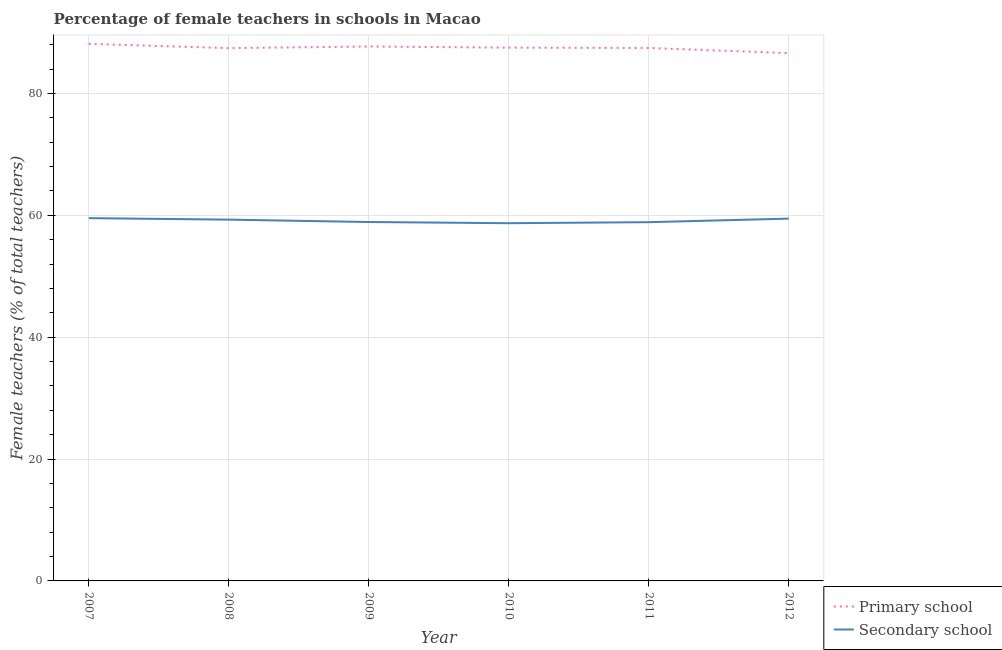How many different coloured lines are there?
Offer a terse response. 2. What is the percentage of female teachers in secondary schools in 2009?
Provide a short and direct response. 58.9. Across all years, what is the maximum percentage of female teachers in secondary schools?
Give a very brief answer. 59.53. Across all years, what is the minimum percentage of female teachers in primary schools?
Keep it short and to the point. 86.61. In which year was the percentage of female teachers in secondary schools maximum?
Give a very brief answer. 2007. In which year was the percentage of female teachers in secondary schools minimum?
Your response must be concise. 2010. What is the total percentage of female teachers in secondary schools in the graph?
Keep it short and to the point. 354.73. What is the difference between the percentage of female teachers in secondary schools in 2008 and that in 2009?
Your answer should be very brief. 0.39. What is the difference between the percentage of female teachers in primary schools in 2007 and the percentage of female teachers in secondary schools in 2012?
Your answer should be very brief. 28.68. What is the average percentage of female teachers in primary schools per year?
Keep it short and to the point. 87.47. In the year 2007, what is the difference between the percentage of female teachers in secondary schools and percentage of female teachers in primary schools?
Ensure brevity in your answer.  -28.6. In how many years, is the percentage of female teachers in secondary schools greater than 72 %?
Your answer should be compact. 0. What is the ratio of the percentage of female teachers in primary schools in 2008 to that in 2011?
Your answer should be very brief. 1. What is the difference between the highest and the second highest percentage of female teachers in primary schools?
Give a very brief answer. 0.44. What is the difference between the highest and the lowest percentage of female teachers in secondary schools?
Give a very brief answer. 0.83. How many lines are there?
Keep it short and to the point. 2. How many years are there in the graph?
Provide a succinct answer. 6. Does the graph contain grids?
Keep it short and to the point. Yes. How are the legend labels stacked?
Your answer should be compact. Vertical. What is the title of the graph?
Give a very brief answer. Percentage of female teachers in schools in Macao. What is the label or title of the X-axis?
Your answer should be very brief. Year. What is the label or title of the Y-axis?
Keep it short and to the point. Female teachers (% of total teachers). What is the Female teachers (% of total teachers) of Primary school in 2007?
Your response must be concise. 88.13. What is the Female teachers (% of total teachers) in Secondary school in 2007?
Make the answer very short. 59.53. What is the Female teachers (% of total teachers) in Primary school in 2008?
Keep it short and to the point. 87.43. What is the Female teachers (% of total teachers) of Secondary school in 2008?
Your response must be concise. 59.29. What is the Female teachers (% of total teachers) of Primary school in 2009?
Ensure brevity in your answer.  87.7. What is the Female teachers (% of total teachers) in Secondary school in 2009?
Offer a terse response. 58.9. What is the Female teachers (% of total teachers) of Primary school in 2010?
Offer a very short reply. 87.51. What is the Female teachers (% of total teachers) of Secondary school in 2010?
Offer a very short reply. 58.7. What is the Female teachers (% of total teachers) of Primary school in 2011?
Offer a very short reply. 87.45. What is the Female teachers (% of total teachers) in Secondary school in 2011?
Give a very brief answer. 58.87. What is the Female teachers (% of total teachers) of Primary school in 2012?
Make the answer very short. 86.61. What is the Female teachers (% of total teachers) in Secondary school in 2012?
Give a very brief answer. 59.45. Across all years, what is the maximum Female teachers (% of total teachers) of Primary school?
Make the answer very short. 88.13. Across all years, what is the maximum Female teachers (% of total teachers) in Secondary school?
Make the answer very short. 59.53. Across all years, what is the minimum Female teachers (% of total teachers) in Primary school?
Offer a terse response. 86.61. Across all years, what is the minimum Female teachers (% of total teachers) of Secondary school?
Your answer should be compact. 58.7. What is the total Female teachers (% of total teachers) of Primary school in the graph?
Make the answer very short. 524.84. What is the total Female teachers (% of total teachers) of Secondary school in the graph?
Make the answer very short. 354.73. What is the difference between the Female teachers (% of total teachers) of Primary school in 2007 and that in 2008?
Give a very brief answer. 0.7. What is the difference between the Female teachers (% of total teachers) in Secondary school in 2007 and that in 2008?
Your answer should be compact. 0.25. What is the difference between the Female teachers (% of total teachers) of Primary school in 2007 and that in 2009?
Your response must be concise. 0.44. What is the difference between the Female teachers (% of total teachers) in Secondary school in 2007 and that in 2009?
Keep it short and to the point. 0.64. What is the difference between the Female teachers (% of total teachers) in Primary school in 2007 and that in 2010?
Keep it short and to the point. 0.63. What is the difference between the Female teachers (% of total teachers) of Secondary school in 2007 and that in 2010?
Your answer should be compact. 0.83. What is the difference between the Female teachers (% of total teachers) of Primary school in 2007 and that in 2011?
Provide a short and direct response. 0.68. What is the difference between the Female teachers (% of total teachers) in Secondary school in 2007 and that in 2011?
Your answer should be very brief. 0.66. What is the difference between the Female teachers (% of total teachers) of Primary school in 2007 and that in 2012?
Your response must be concise. 1.52. What is the difference between the Female teachers (% of total teachers) of Secondary school in 2007 and that in 2012?
Provide a succinct answer. 0.08. What is the difference between the Female teachers (% of total teachers) of Primary school in 2008 and that in 2009?
Provide a short and direct response. -0.26. What is the difference between the Female teachers (% of total teachers) in Secondary school in 2008 and that in 2009?
Your answer should be very brief. 0.39. What is the difference between the Female teachers (% of total teachers) in Primary school in 2008 and that in 2010?
Offer a terse response. -0.08. What is the difference between the Female teachers (% of total teachers) in Secondary school in 2008 and that in 2010?
Ensure brevity in your answer.  0.59. What is the difference between the Female teachers (% of total teachers) in Primary school in 2008 and that in 2011?
Your response must be concise. -0.02. What is the difference between the Female teachers (% of total teachers) in Secondary school in 2008 and that in 2011?
Provide a short and direct response. 0.41. What is the difference between the Female teachers (% of total teachers) of Primary school in 2008 and that in 2012?
Your response must be concise. 0.82. What is the difference between the Female teachers (% of total teachers) of Secondary school in 2008 and that in 2012?
Offer a very short reply. -0.17. What is the difference between the Female teachers (% of total teachers) in Primary school in 2009 and that in 2010?
Give a very brief answer. 0.19. What is the difference between the Female teachers (% of total teachers) of Secondary school in 2009 and that in 2010?
Your response must be concise. 0.2. What is the difference between the Female teachers (% of total teachers) of Primary school in 2009 and that in 2011?
Give a very brief answer. 0.24. What is the difference between the Female teachers (% of total teachers) of Secondary school in 2009 and that in 2011?
Offer a very short reply. 0.03. What is the difference between the Female teachers (% of total teachers) of Primary school in 2009 and that in 2012?
Offer a very short reply. 1.08. What is the difference between the Female teachers (% of total teachers) in Secondary school in 2009 and that in 2012?
Keep it short and to the point. -0.56. What is the difference between the Female teachers (% of total teachers) of Primary school in 2010 and that in 2011?
Provide a succinct answer. 0.05. What is the difference between the Female teachers (% of total teachers) of Secondary school in 2010 and that in 2011?
Your response must be concise. -0.17. What is the difference between the Female teachers (% of total teachers) in Primary school in 2010 and that in 2012?
Give a very brief answer. 0.9. What is the difference between the Female teachers (% of total teachers) in Secondary school in 2010 and that in 2012?
Your answer should be compact. -0.75. What is the difference between the Female teachers (% of total teachers) in Primary school in 2011 and that in 2012?
Your answer should be compact. 0.84. What is the difference between the Female teachers (% of total teachers) of Secondary school in 2011 and that in 2012?
Give a very brief answer. -0.58. What is the difference between the Female teachers (% of total teachers) in Primary school in 2007 and the Female teachers (% of total teachers) in Secondary school in 2008?
Your answer should be compact. 28.85. What is the difference between the Female teachers (% of total teachers) in Primary school in 2007 and the Female teachers (% of total teachers) in Secondary school in 2009?
Make the answer very short. 29.24. What is the difference between the Female teachers (% of total teachers) of Primary school in 2007 and the Female teachers (% of total teachers) of Secondary school in 2010?
Give a very brief answer. 29.43. What is the difference between the Female teachers (% of total teachers) of Primary school in 2007 and the Female teachers (% of total teachers) of Secondary school in 2011?
Your answer should be very brief. 29.26. What is the difference between the Female teachers (% of total teachers) in Primary school in 2007 and the Female teachers (% of total teachers) in Secondary school in 2012?
Ensure brevity in your answer.  28.68. What is the difference between the Female teachers (% of total teachers) of Primary school in 2008 and the Female teachers (% of total teachers) of Secondary school in 2009?
Offer a terse response. 28.54. What is the difference between the Female teachers (% of total teachers) of Primary school in 2008 and the Female teachers (% of total teachers) of Secondary school in 2010?
Offer a terse response. 28.73. What is the difference between the Female teachers (% of total teachers) of Primary school in 2008 and the Female teachers (% of total teachers) of Secondary school in 2011?
Your answer should be compact. 28.56. What is the difference between the Female teachers (% of total teachers) in Primary school in 2008 and the Female teachers (% of total teachers) in Secondary school in 2012?
Your answer should be compact. 27.98. What is the difference between the Female teachers (% of total teachers) of Primary school in 2009 and the Female teachers (% of total teachers) of Secondary school in 2010?
Offer a terse response. 29. What is the difference between the Female teachers (% of total teachers) of Primary school in 2009 and the Female teachers (% of total teachers) of Secondary school in 2011?
Provide a succinct answer. 28.83. What is the difference between the Female teachers (% of total teachers) in Primary school in 2009 and the Female teachers (% of total teachers) in Secondary school in 2012?
Ensure brevity in your answer.  28.25. What is the difference between the Female teachers (% of total teachers) of Primary school in 2010 and the Female teachers (% of total teachers) of Secondary school in 2011?
Keep it short and to the point. 28.64. What is the difference between the Female teachers (% of total teachers) in Primary school in 2010 and the Female teachers (% of total teachers) in Secondary school in 2012?
Make the answer very short. 28.06. What is the difference between the Female teachers (% of total teachers) in Primary school in 2011 and the Female teachers (% of total teachers) in Secondary school in 2012?
Provide a short and direct response. 28. What is the average Female teachers (% of total teachers) in Primary school per year?
Your response must be concise. 87.47. What is the average Female teachers (% of total teachers) in Secondary school per year?
Offer a terse response. 59.12. In the year 2007, what is the difference between the Female teachers (% of total teachers) in Primary school and Female teachers (% of total teachers) in Secondary school?
Your answer should be very brief. 28.6. In the year 2008, what is the difference between the Female teachers (% of total teachers) of Primary school and Female teachers (% of total teachers) of Secondary school?
Provide a short and direct response. 28.15. In the year 2009, what is the difference between the Female teachers (% of total teachers) in Primary school and Female teachers (% of total teachers) in Secondary school?
Offer a very short reply. 28.8. In the year 2010, what is the difference between the Female teachers (% of total teachers) of Primary school and Female teachers (% of total teachers) of Secondary school?
Give a very brief answer. 28.81. In the year 2011, what is the difference between the Female teachers (% of total teachers) of Primary school and Female teachers (% of total teachers) of Secondary school?
Offer a very short reply. 28.58. In the year 2012, what is the difference between the Female teachers (% of total teachers) of Primary school and Female teachers (% of total teachers) of Secondary school?
Offer a very short reply. 27.16. What is the ratio of the Female teachers (% of total teachers) of Primary school in 2007 to that in 2008?
Offer a terse response. 1.01. What is the ratio of the Female teachers (% of total teachers) in Secondary school in 2007 to that in 2008?
Your response must be concise. 1. What is the ratio of the Female teachers (% of total teachers) of Primary school in 2007 to that in 2009?
Provide a short and direct response. 1. What is the ratio of the Female teachers (% of total teachers) of Secondary school in 2007 to that in 2009?
Make the answer very short. 1.01. What is the ratio of the Female teachers (% of total teachers) of Primary school in 2007 to that in 2010?
Give a very brief answer. 1.01. What is the ratio of the Female teachers (% of total teachers) of Secondary school in 2007 to that in 2010?
Your answer should be very brief. 1.01. What is the ratio of the Female teachers (% of total teachers) in Secondary school in 2007 to that in 2011?
Provide a succinct answer. 1.01. What is the ratio of the Female teachers (% of total teachers) of Primary school in 2007 to that in 2012?
Your answer should be compact. 1.02. What is the ratio of the Female teachers (% of total teachers) in Secondary school in 2007 to that in 2012?
Offer a terse response. 1. What is the ratio of the Female teachers (% of total teachers) in Primary school in 2008 to that in 2009?
Make the answer very short. 1. What is the ratio of the Female teachers (% of total teachers) of Secondary school in 2008 to that in 2009?
Provide a succinct answer. 1.01. What is the ratio of the Female teachers (% of total teachers) in Primary school in 2008 to that in 2010?
Your answer should be compact. 1. What is the ratio of the Female teachers (% of total teachers) in Secondary school in 2008 to that in 2010?
Make the answer very short. 1.01. What is the ratio of the Female teachers (% of total teachers) in Primary school in 2008 to that in 2012?
Offer a very short reply. 1.01. What is the ratio of the Female teachers (% of total teachers) in Primary school in 2009 to that in 2010?
Offer a terse response. 1. What is the ratio of the Female teachers (% of total teachers) in Secondary school in 2009 to that in 2011?
Your answer should be very brief. 1. What is the ratio of the Female teachers (% of total teachers) of Primary school in 2009 to that in 2012?
Provide a succinct answer. 1.01. What is the ratio of the Female teachers (% of total teachers) of Secondary school in 2009 to that in 2012?
Your answer should be very brief. 0.99. What is the ratio of the Female teachers (% of total teachers) in Primary school in 2010 to that in 2011?
Your answer should be very brief. 1. What is the ratio of the Female teachers (% of total teachers) of Secondary school in 2010 to that in 2011?
Offer a very short reply. 1. What is the ratio of the Female teachers (% of total teachers) in Primary school in 2010 to that in 2012?
Offer a very short reply. 1.01. What is the ratio of the Female teachers (% of total teachers) in Secondary school in 2010 to that in 2012?
Keep it short and to the point. 0.99. What is the ratio of the Female teachers (% of total teachers) of Primary school in 2011 to that in 2012?
Your answer should be very brief. 1.01. What is the ratio of the Female teachers (% of total teachers) in Secondary school in 2011 to that in 2012?
Give a very brief answer. 0.99. What is the difference between the highest and the second highest Female teachers (% of total teachers) of Primary school?
Make the answer very short. 0.44. What is the difference between the highest and the second highest Female teachers (% of total teachers) of Secondary school?
Offer a very short reply. 0.08. What is the difference between the highest and the lowest Female teachers (% of total teachers) in Primary school?
Offer a very short reply. 1.52. What is the difference between the highest and the lowest Female teachers (% of total teachers) of Secondary school?
Make the answer very short. 0.83. 